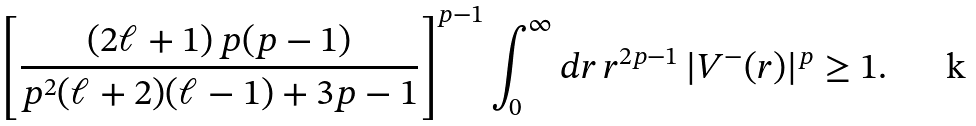Convert formula to latex. <formula><loc_0><loc_0><loc_500><loc_500>\left [ \frac { ( 2 \ell + 1 ) \, p ( p - 1 ) } { p ^ { 2 } ( \ell + 2 ) ( \ell - 1 ) + 3 p - 1 } \right ] ^ { p - 1 } \int _ { 0 } ^ { \infty } d r \, r ^ { 2 p - 1 } \, | V ^ { - } ( r ) | ^ { p } \geq 1 .</formula> 